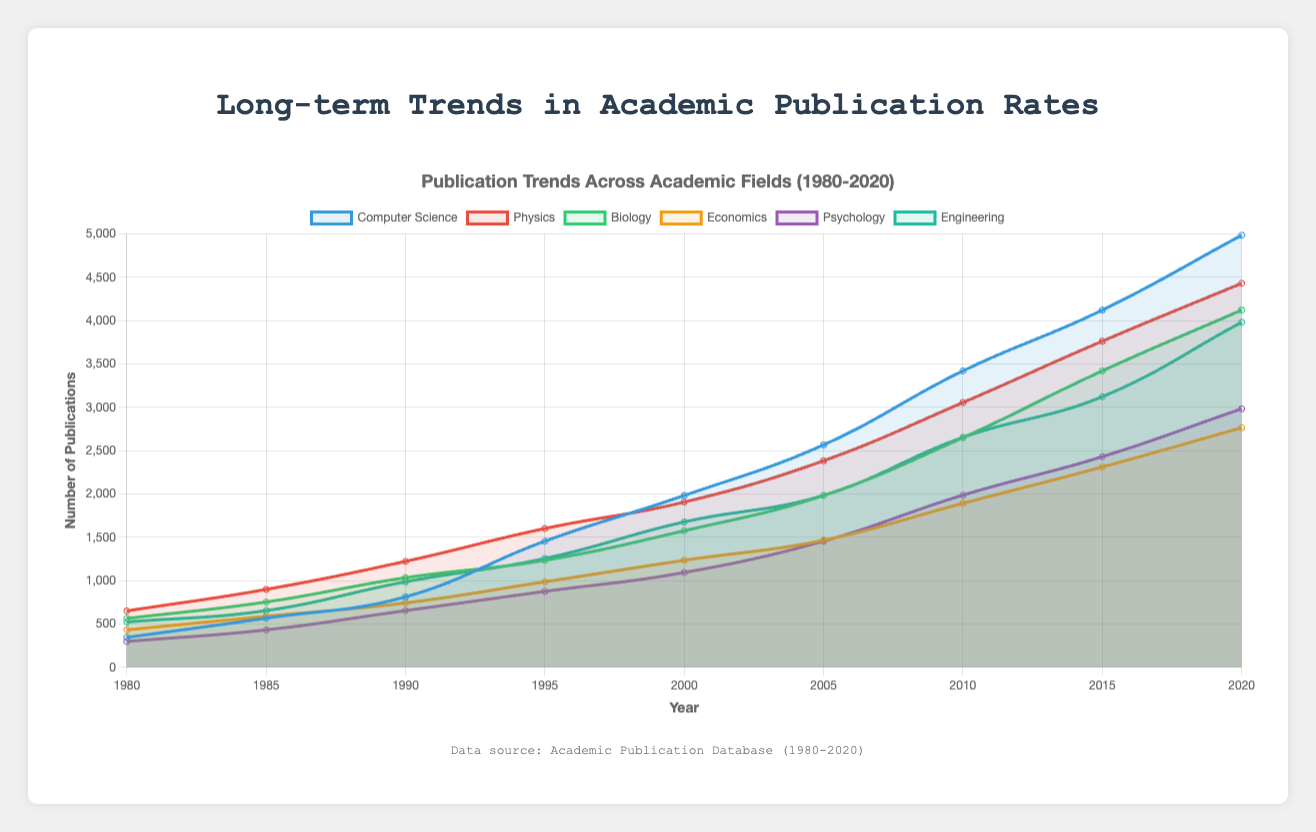Which field showed the highest number of publications in 2020? To find the field with the highest number of publications in 2020, look at the end of each trend line for 2020 and compare the final values. Computer Science has the highest with 4987 publications.
Answer: Computer Science How did the number of publications in Economics in 2005 compare to those in 1995? To compare, look at the publication points for Economics in 1995 (987) and 2005 (1467). There is an increase from 987 in 1995 to 1467 in 2005.
Answer: Increase Which field had the slowest growth in publications from 1980 to 2020? Calculate the difference in publications from 1980 to 2020 for each field and compare these differences. Psychology goes from 298 to 2984, a difference of 2686; other fields show larger increases; hence, Psychology had the slowest growth.
Answer: Psychology Between 1995 and 2000, which field experienced the largest increase in publications? Find the increase by subtracting the number of publications in 1995 from the number in 2000 for each field. Computer Science had the largest increase: 1983 - 1456 = 527.
Answer: Computer Science What is the percentage increase in Biology publications from 2000 to 2010? To find the percentage increase, use the formula [(new number - old number) / old number] x 100. For Biology, from 2000 (1576) to 2010 (2651), the increase is [(2651 - 1576) / 1576] x 100 ≈ 68.3%.
Answer: 68.3% Which year showed the most significant increase in publications for all fields on average? Calculate the yearly change for each field, then average these changes for each year. Identify the year with the highest average increase. From 1990 to 1995, most fields show substantial increases.
Answer: 1990 to 1995 How much more were the publications in Physics in 2010 compared to Psychology in the same year? Subtract the number of publications in Psychology (1987) from those in Physics (3056) for 2010: 3056 - 1987 = 1069.
Answer: 1069 What was the average number of publications across all fields in 1980? Sum the publications for all fields in 1980 and divide by the number of fields. Sum: 345 + 651 + 564 + 432 + 298 + 523 = 2813. Average: 2813 / 6 ≈ 469.
Answer: 469 